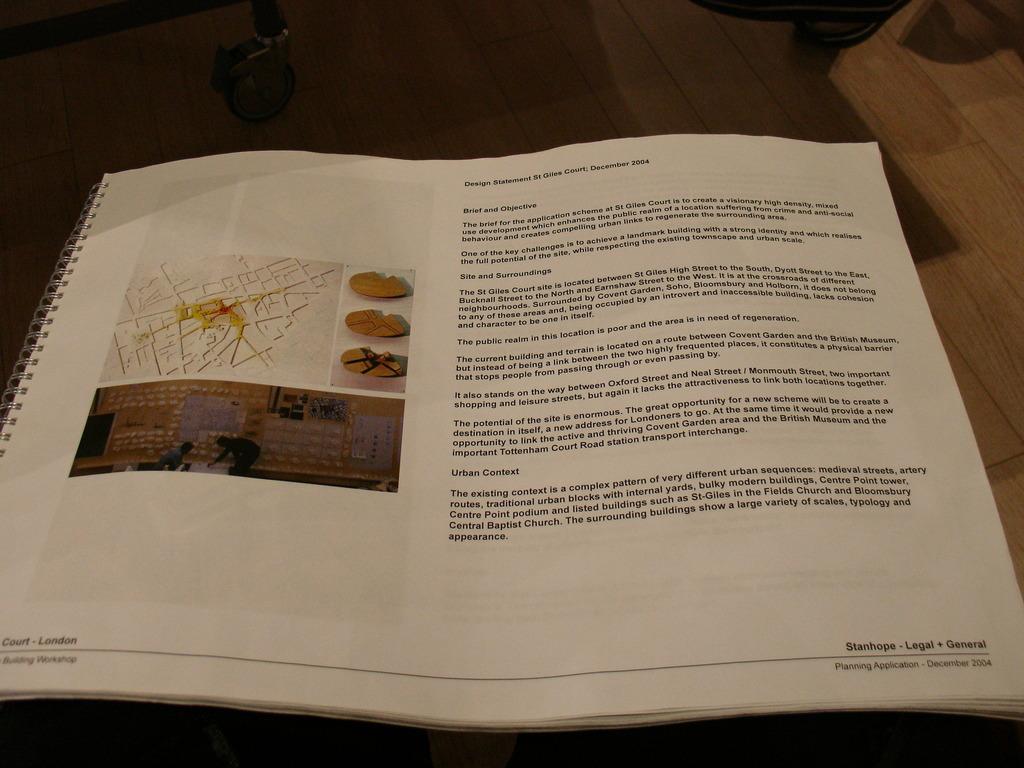What is the first word on the page?
Provide a short and direct response. Design. 